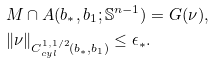<formula> <loc_0><loc_0><loc_500><loc_500>& M \cap A ( b _ { * } , b _ { 1 } ; \mathbb { S } ^ { n - 1 } ) = G ( \nu ) , \\ & \| \nu \| _ { C ^ { 1 , 1 / 2 } _ { c y l } ( b _ { * } , b _ { 1 } ) } \leq \epsilon _ { * } .</formula> 